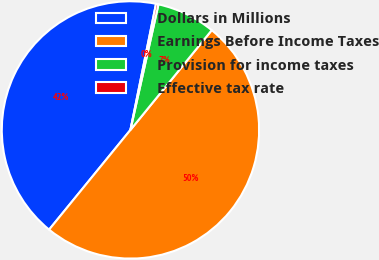Convert chart to OTSL. <chart><loc_0><loc_0><loc_500><loc_500><pie_chart><fcel>Dollars in Millions<fcel>Earnings Before Income Taxes<fcel>Provision for income taxes<fcel>Effective tax rate<nl><fcel>42.29%<fcel>50.0%<fcel>7.39%<fcel>0.31%<nl></chart> 